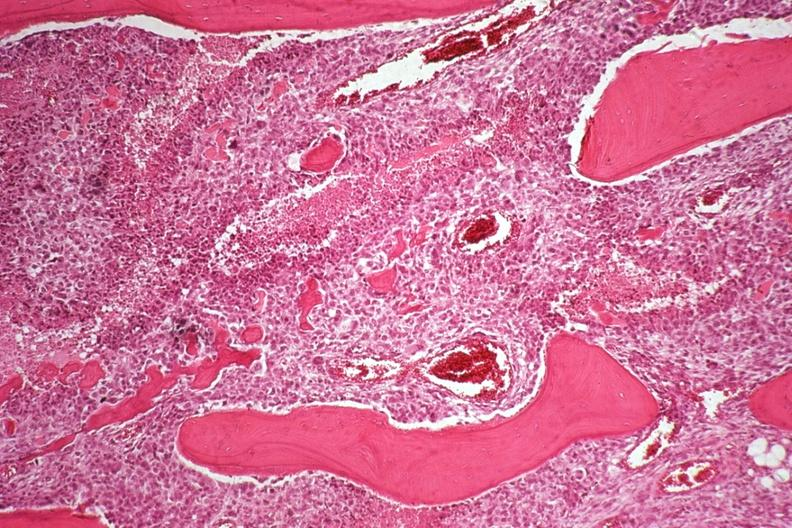what does this image show?
Answer the question using a single word or phrase. Neoplastic osteoblasts and tumor osteoid 